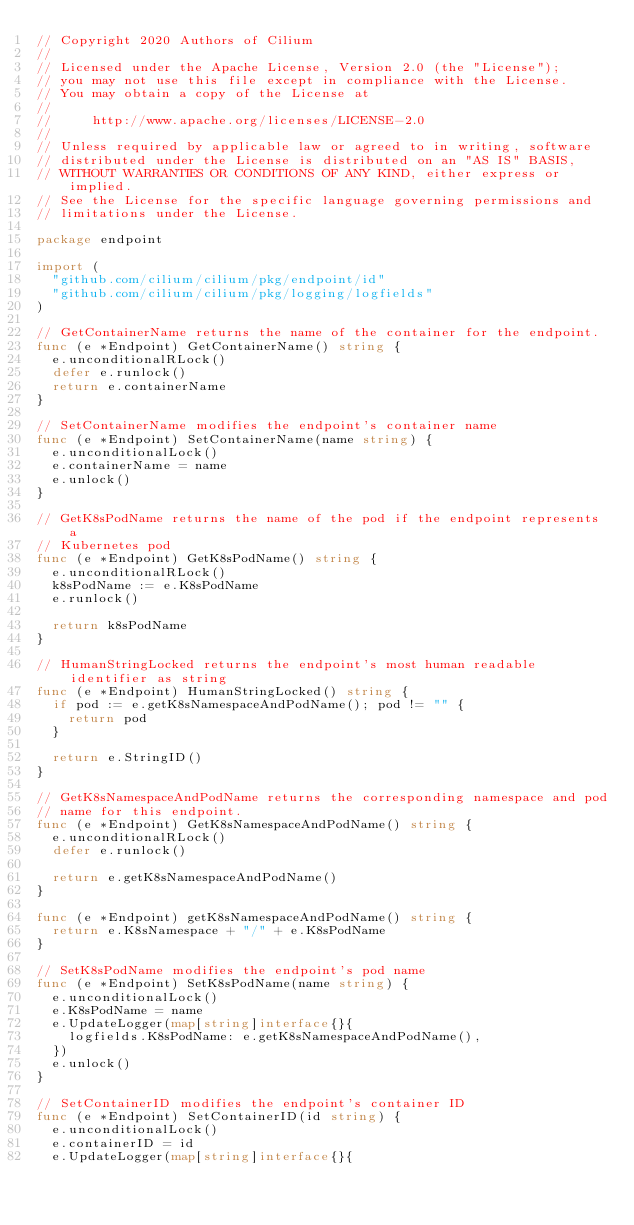Convert code to text. <code><loc_0><loc_0><loc_500><loc_500><_Go_>// Copyright 2020 Authors of Cilium
//
// Licensed under the Apache License, Version 2.0 (the "License");
// you may not use this file except in compliance with the License.
// You may obtain a copy of the License at
//
//     http://www.apache.org/licenses/LICENSE-2.0
//
// Unless required by applicable law or agreed to in writing, software
// distributed under the License is distributed on an "AS IS" BASIS,
// WITHOUT WARRANTIES OR CONDITIONS OF ANY KIND, either express or implied.
// See the License for the specific language governing permissions and
// limitations under the License.

package endpoint

import (
	"github.com/cilium/cilium/pkg/endpoint/id"
	"github.com/cilium/cilium/pkg/logging/logfields"
)

// GetContainerName returns the name of the container for the endpoint.
func (e *Endpoint) GetContainerName() string {
	e.unconditionalRLock()
	defer e.runlock()
	return e.containerName
}

// SetContainerName modifies the endpoint's container name
func (e *Endpoint) SetContainerName(name string) {
	e.unconditionalLock()
	e.containerName = name
	e.unlock()
}

// GetK8sPodName returns the name of the pod if the endpoint represents a
// Kubernetes pod
func (e *Endpoint) GetK8sPodName() string {
	e.unconditionalRLock()
	k8sPodName := e.K8sPodName
	e.runlock()

	return k8sPodName
}

// HumanStringLocked returns the endpoint's most human readable identifier as string
func (e *Endpoint) HumanStringLocked() string {
	if pod := e.getK8sNamespaceAndPodName(); pod != "" {
		return pod
	}

	return e.StringID()
}

// GetK8sNamespaceAndPodName returns the corresponding namespace and pod
// name for this endpoint.
func (e *Endpoint) GetK8sNamespaceAndPodName() string {
	e.unconditionalRLock()
	defer e.runlock()

	return e.getK8sNamespaceAndPodName()
}

func (e *Endpoint) getK8sNamespaceAndPodName() string {
	return e.K8sNamespace + "/" + e.K8sPodName
}

// SetK8sPodName modifies the endpoint's pod name
func (e *Endpoint) SetK8sPodName(name string) {
	e.unconditionalLock()
	e.K8sPodName = name
	e.UpdateLogger(map[string]interface{}{
		logfields.K8sPodName: e.getK8sNamespaceAndPodName(),
	})
	e.unlock()
}

// SetContainerID modifies the endpoint's container ID
func (e *Endpoint) SetContainerID(id string) {
	e.unconditionalLock()
	e.containerID = id
	e.UpdateLogger(map[string]interface{}{</code> 